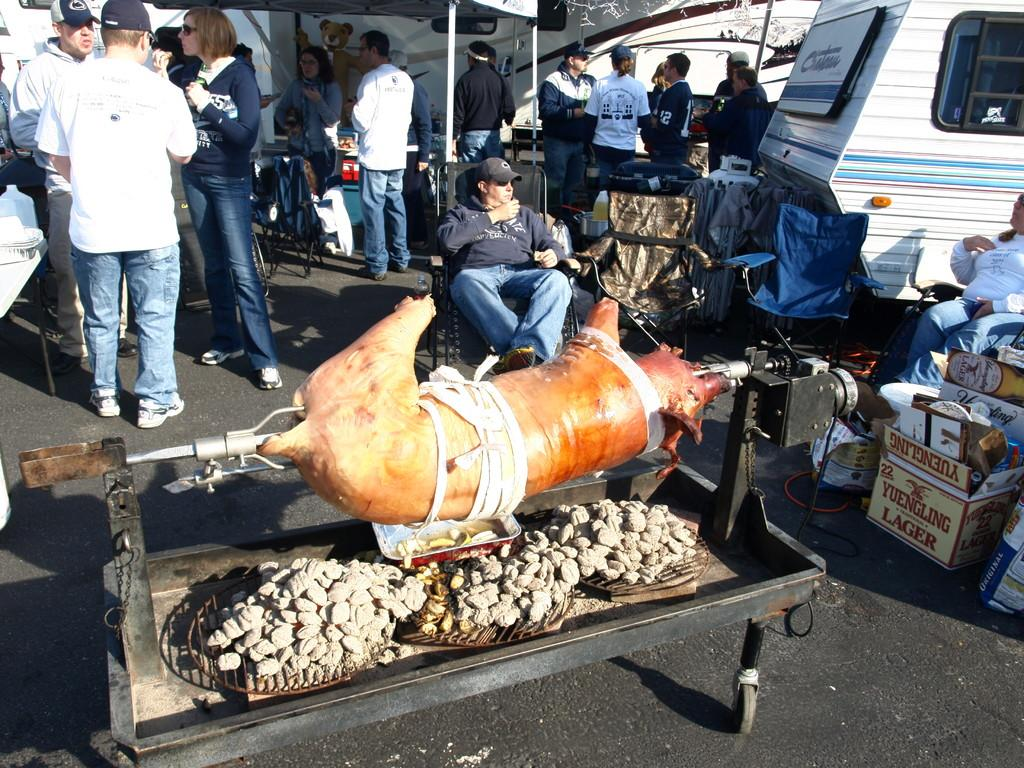What can be seen hanging on a surface in the image? There are dishes hanging on a surface in the image. Who or what can be seen in the image? There are people visible in the image. What type of transportation is present in the image? Vehicles are present in the image. What type of structure can be seen in the image? There is a shed in the image. What is on the road in the image? There are objects on the road in the image}. What type of trousers are the people wearing in the image? There is no information about the type of trousers the people are wearing in the image. Can you tell me if the vehicles in the image have received approval for use? There is no information about the approval status of the vehicles in the image. 